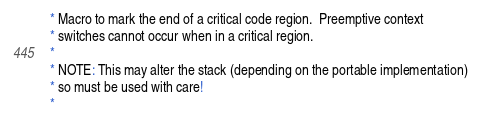<code> <loc_0><loc_0><loc_500><loc_500><_C_> * Macro to mark the end of a critical code region.  Preemptive context
 * switches cannot occur when in a critical region.
 *
 * NOTE: This may alter the stack (depending on the portable implementation)
 * so must be used with care!
 *</code> 